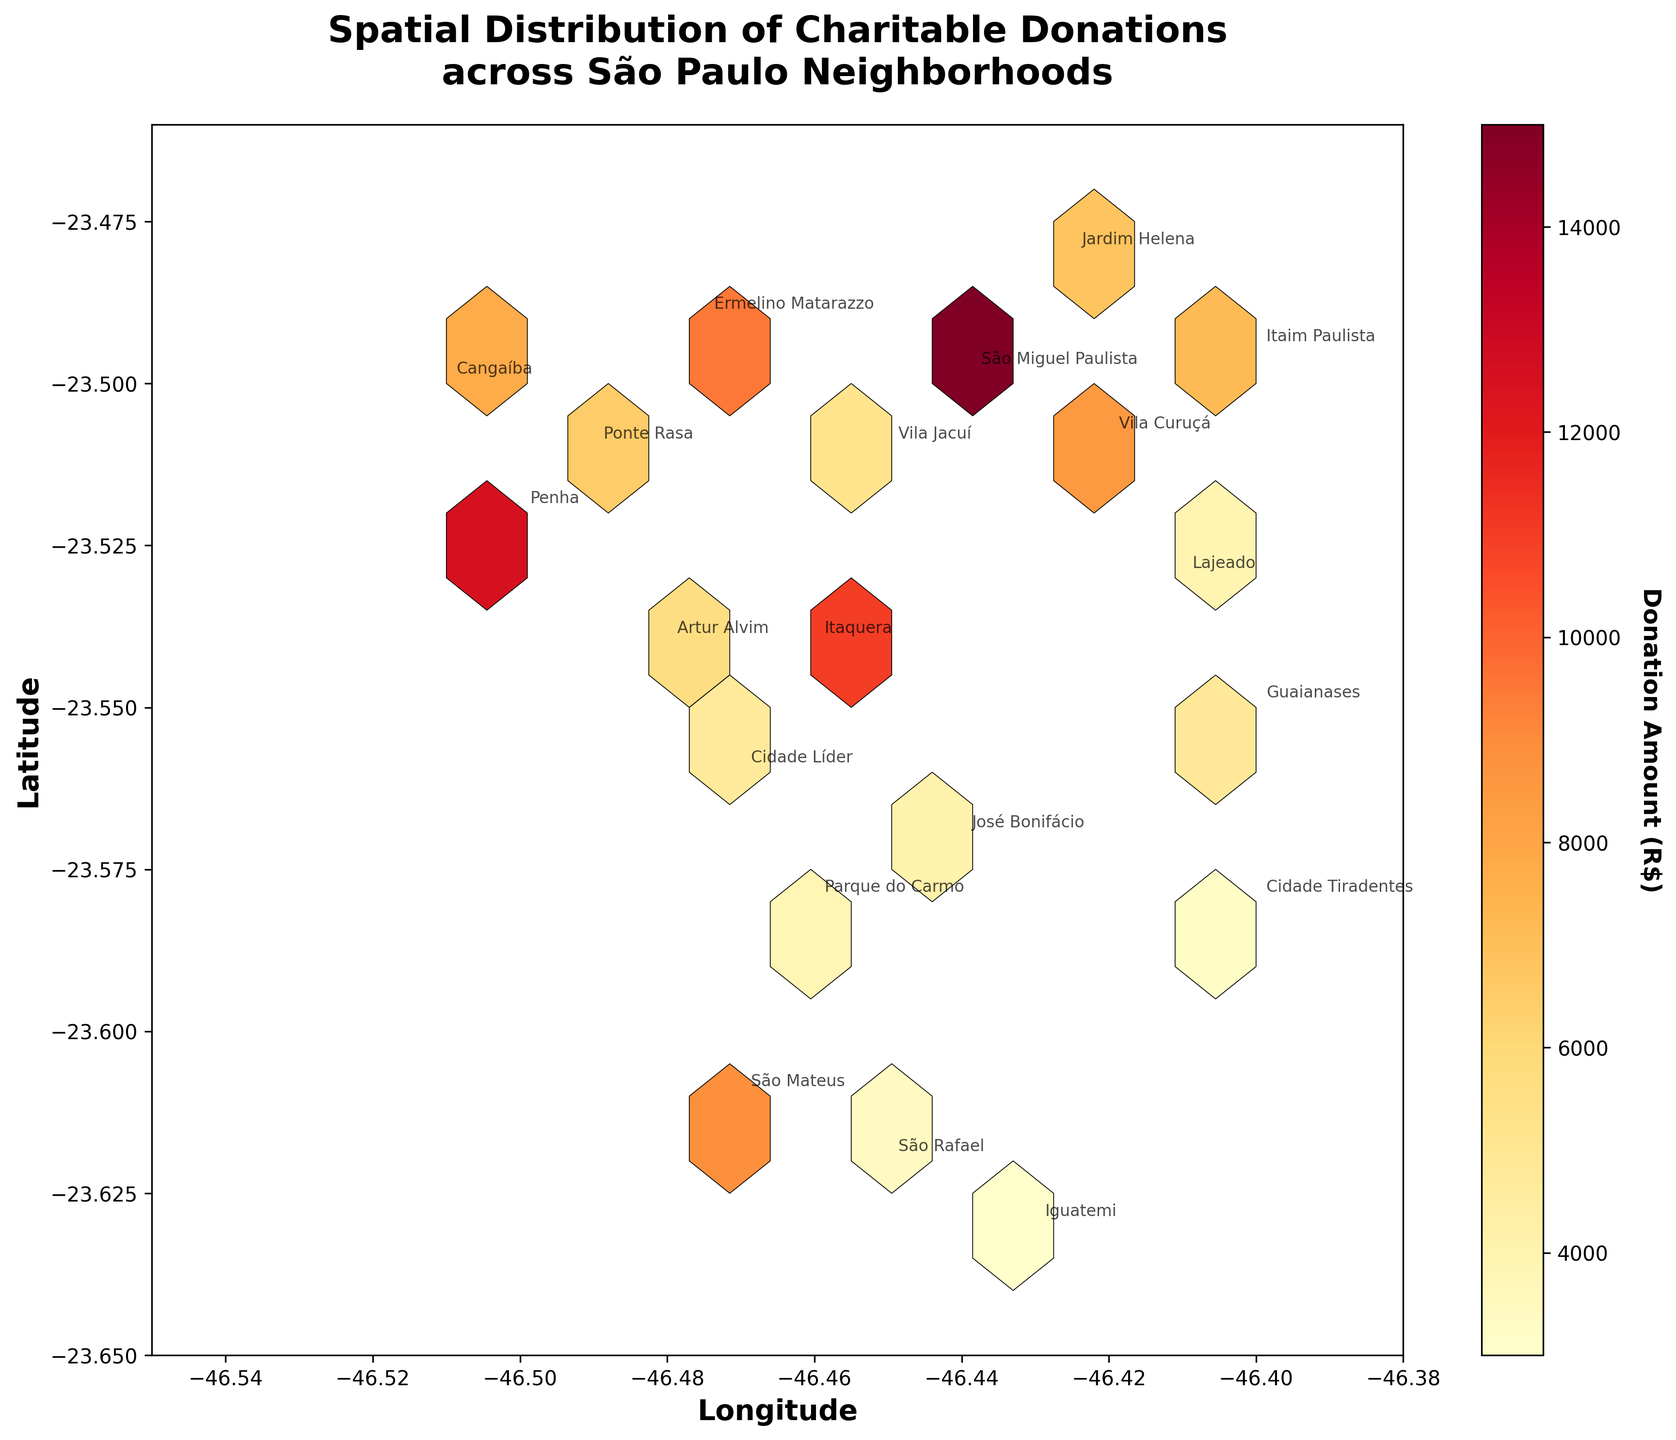What is the title of the plot? The title of the plot is typically placed at the top center. It reads "Spatial Distribution of Charitable Donations across São Paulo Neighborhoods".
Answer: Spatial Distribution of Charitable Donations across São Paulo Neighborhoods What do the color variations represent in the hexagonal bins? Color variations in the hexagonal bins denote different ranges of donation amounts, with the color key indicating that warmer colors (e.g., yellow, orange, red) represent higher donation amounts.
Answer: Donation amounts What range of longitudes is covered in this plot? The x-axis label and range are used to determine this. The plot's x-axis, representing longitude, ranges approximately from -46.55 to -46.38.
Answer: -46.55 to -46.38 Which neighborhood shows the highest contribution? Upon observing the annotated neighborhood names and the color intensity in Hexbin Plot, São Miguel Paulista shows the highest contribution with an amount of R$15,000, as evidenced by the most prominent color.
Answer: São Miguel Paulista How does the donation amount in Ermelino Matarazzo compare to that in Vila Jacuí? Looking at the annotated text and corresponding colors, Ermelino Matarazzo has a higher donation amount (R$9,500) compared to Vila Jacuí (R$5,200).
Answer: Ermelino Matarazzo has a higher amount What neighborhood is located furthest to the North-East on the plot? The plot's top-right (North-East) area and corresponding annotations will indicate that Itaim Paulista, positioned at coordinates (-23.4950, -46.4000), is the furthest to the North-East.
Answer: Itaim Paulista What is the average donation amount for Itaim Paulista and Jardim Helena? Itaim Paulista has R$7,200 and Jardim Helena has R$6,800. The average is calculated by summing and dividing by 2: (7200 + 6800) / 2 = 7000.
Answer: R$7,000 Which area has fewer donations: Lajeado or Cidade Tiradentes? Observing the annotated values for Lajeado and Cidade Tiradentes, Lajeado has R$3,900 and Cidade Tiradentes has R$3,200 in donations. Therefore, Cidade Tiradentes has fewer donations.
Answer: Cidade Tiradentes What is the total donation amount across all neighborhoods as shown in the plot? By summing up all the individual donation amounts: 15000 + 8500 + 7200 + 6800 + 9500 + 5200 + 11000 + 4800 + 3900 + 3200 + 12500 + 7800 + 6500 + 5600 + 4700 + 4100 + 3800 + 8900 + 3000 + 3400, the total sum is 138,800.
Answer: R$138,800 What is the most densely populated region in terms of donation amount, and how can you tell? The densest region can be identified by observing the highest concentration and most intense coloring of hexagonal bins, generally around São Miguel Paulista and its immediate neighboring regions, as indicated by the color intensity and concentration in that area.
Answer: São Miguel Paulista 